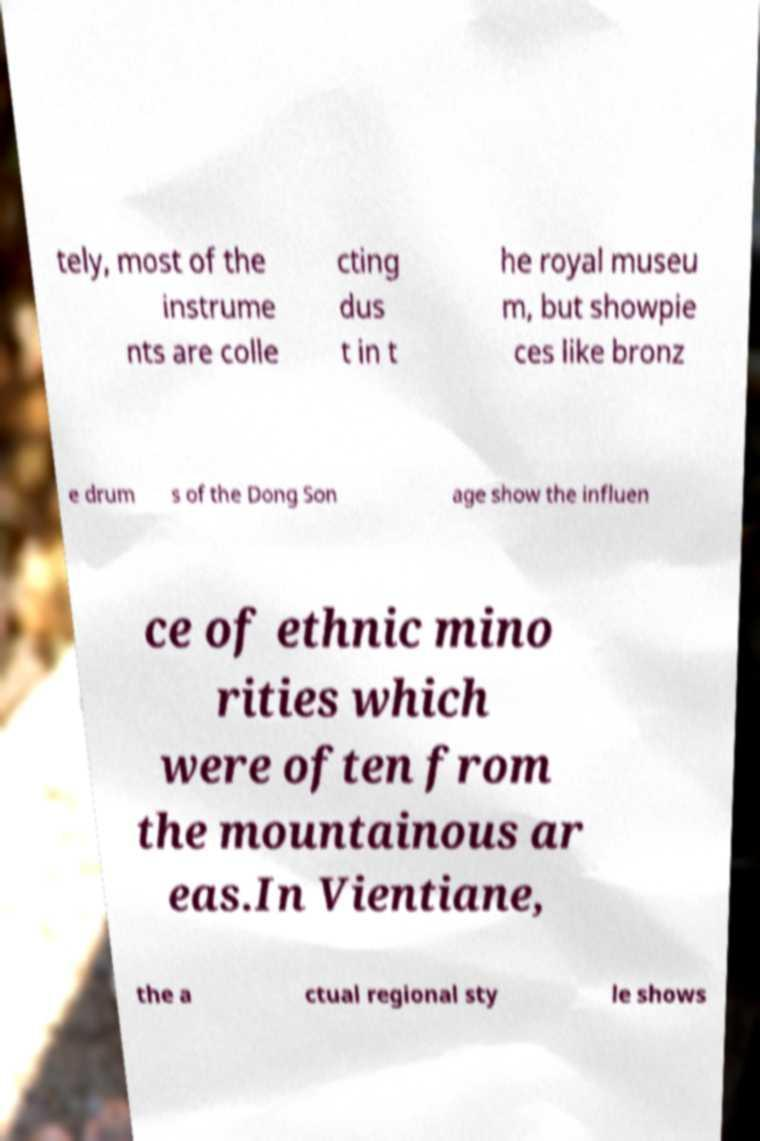Can you accurately transcribe the text from the provided image for me? tely, most of the instrume nts are colle cting dus t in t he royal museu m, but showpie ces like bronz e drum s of the Dong Son age show the influen ce of ethnic mino rities which were often from the mountainous ar eas.In Vientiane, the a ctual regional sty le shows 